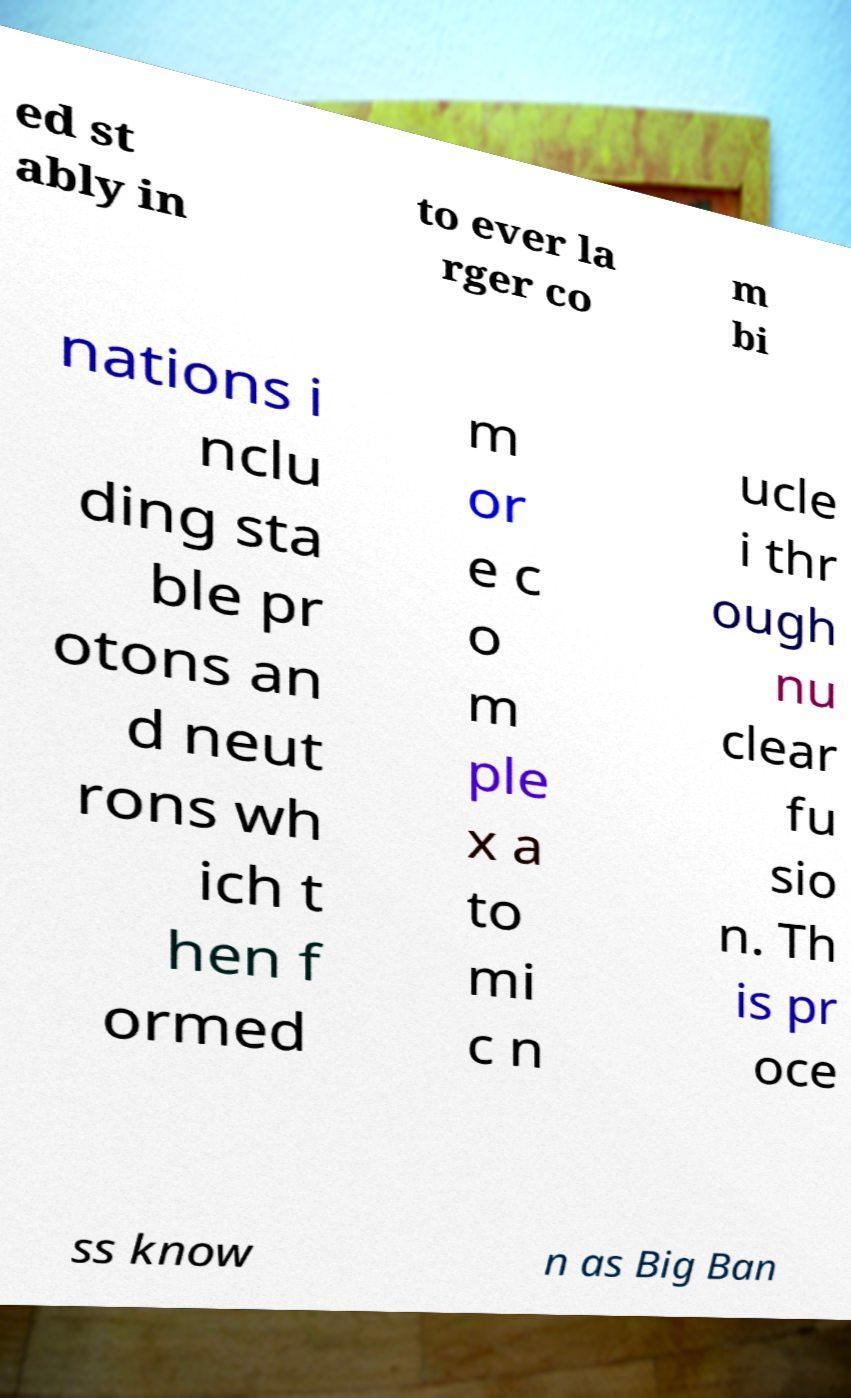Could you assist in decoding the text presented in this image and type it out clearly? ed st ably in to ever la rger co m bi nations i nclu ding sta ble pr otons an d neut rons wh ich t hen f ormed m or e c o m ple x a to mi c n ucle i thr ough nu clear fu sio n. Th is pr oce ss know n as Big Ban 